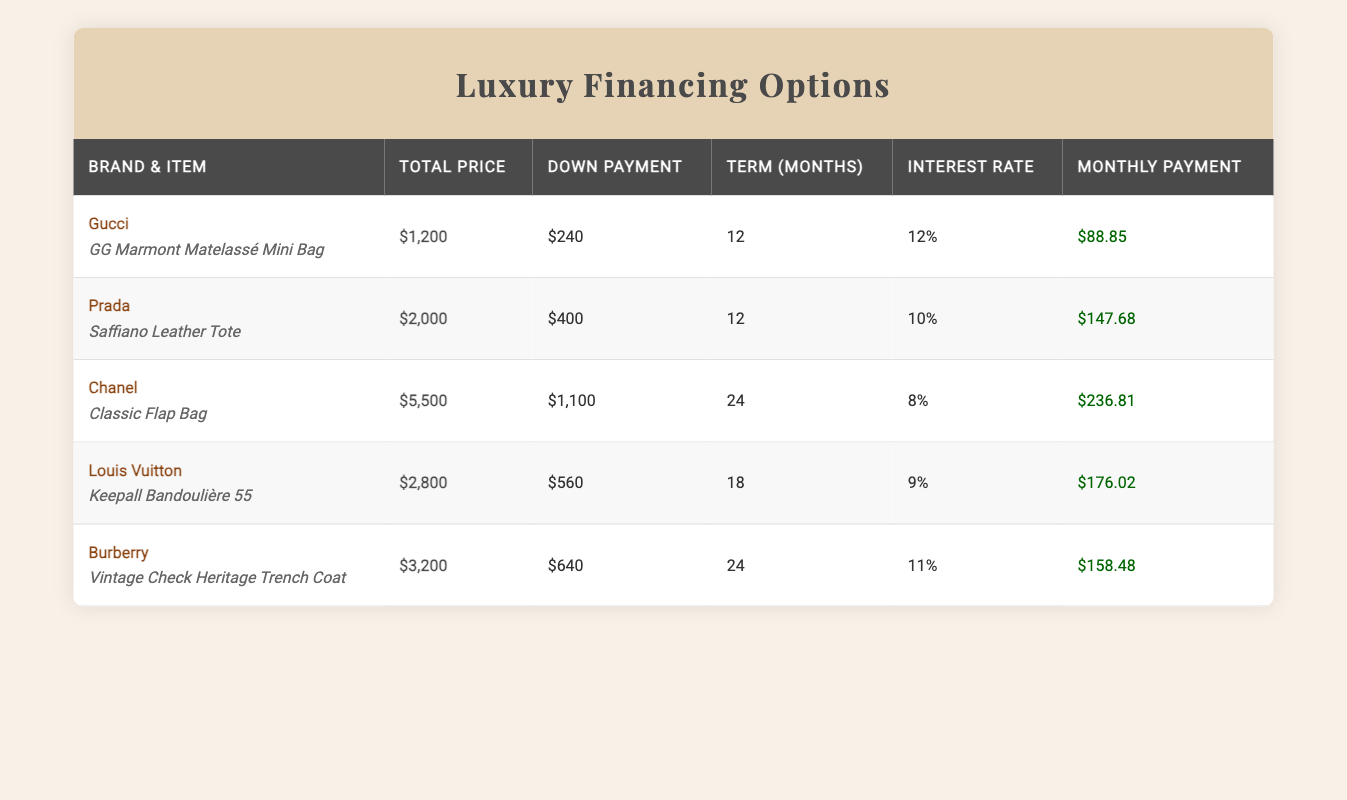What is the total price of the Burberry trench coat? The total price for the Burberry Vintage Check Heritage Trench Coat is listed in the table under the "Total Price" column. It reads $3,200.
Answer: $3,200 What is the monthly payment for the Chanel Classic Flap Bag? The table shows that the monthly payment for the Chanel Classic Flap Bag is found in the "Monthly Payment" column. It is $236.81.
Answer: $236.81 Which item has the highest interest rate and what is it? The highest interest rate can be found by comparing the interest rates in the "Interest Rate" column. Burberry has the highest at 11%.
Answer: Burberry Vintage Check Heritage Trench Coat, 11% How much more is the monthly payment for the Prada item compared to the Gucci item? First, identify the monthly payments: Prada's is $147.68 and Gucci's is $88.85. The difference is calculated as $147.68 - $88.85 = $58.83.
Answer: $58.83 Is the financing term for the Louis Vuitton item longer than the financing term for the Gucci item? The financing term for Louis Vuitton is 18 months, while for Gucci it is 12 months. Since 18 is greater than 12, the statement is true.
Answer: Yes What is the average monthly payment for all items listed? The monthly payments listed are $88.85, $147.68, $236.81, $176.02, and $158.48. First, add them: $88.85 + $147.68 + $236.81 + $176.02 + $158.48 = $807.84. Then divide by 5 (the number of items): $807.84 / 5 = $161.57.
Answer: $161.57 Which brand requires the lowest down payment? By inspecting the "Down Payment" column, we see that Gucci requires $240, Prada requires $400, Chanel requires $1,100, Louis Vuitton requires $560, and Burberry requires $640. The lowest is indeed Gucci at $240.
Answer: Gucci, $240 How much is the total down payment for all items combined? To find the total down payment, sum the down payments: $240 (Gucci) + $400 (Prada) + $1,100 (Chanel) + $560 (Louis Vuitton) + $640 (Burberry) = $3,040.
Answer: $3,040 Does the monthly payment for the Burberry item exceed the payment for the Louis Vuitton item? The monthly payment for Burberry is $158.48 while it is $176.02 for Louis Vuitton. Since $158.48 is less than $176.02, the statement is false.
Answer: No 